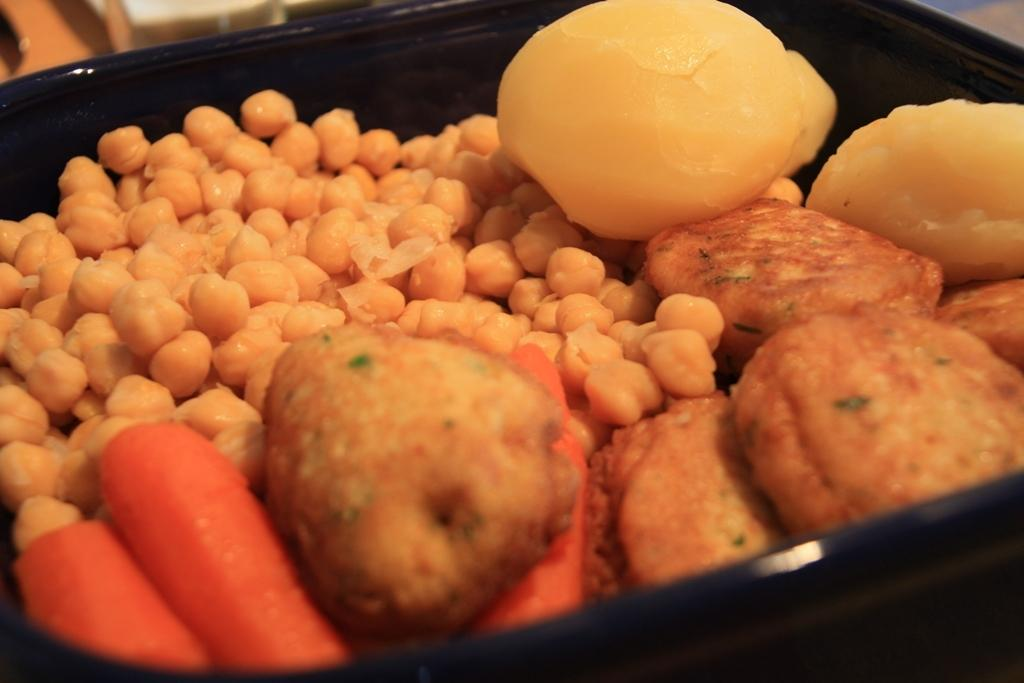What type of food can be seen in the image? There is food in the image, specifically fruits. How are the fruits and food arranged in the image? The fruits and food are placed on a bowl. Can you describe the fruits in the image? The facts provided do not specify the type of fruits, so we cannot describe them. What type of wool is being used to conduct scientific experiments in the image? There is no wool or scientific experiments present in the image; it features fruits and food placed on a bowl. 